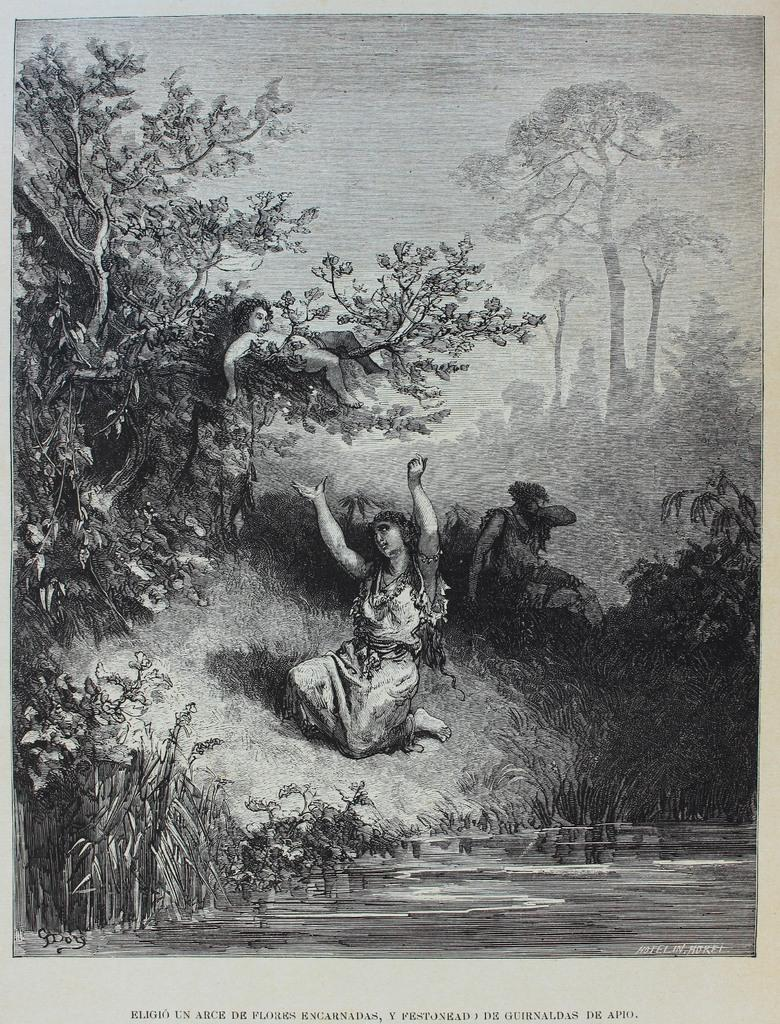What is depicted on the paper in the image? There is an image on the paper. What does the image represent? The image represents people and trees. Is there any text accompanying the image on the paper? Yes, there is text written on the paper. What type of adjustment is being made to the trees in the image? There is no adjustment being made to the trees in the image; it is a static representation of people and trees. 